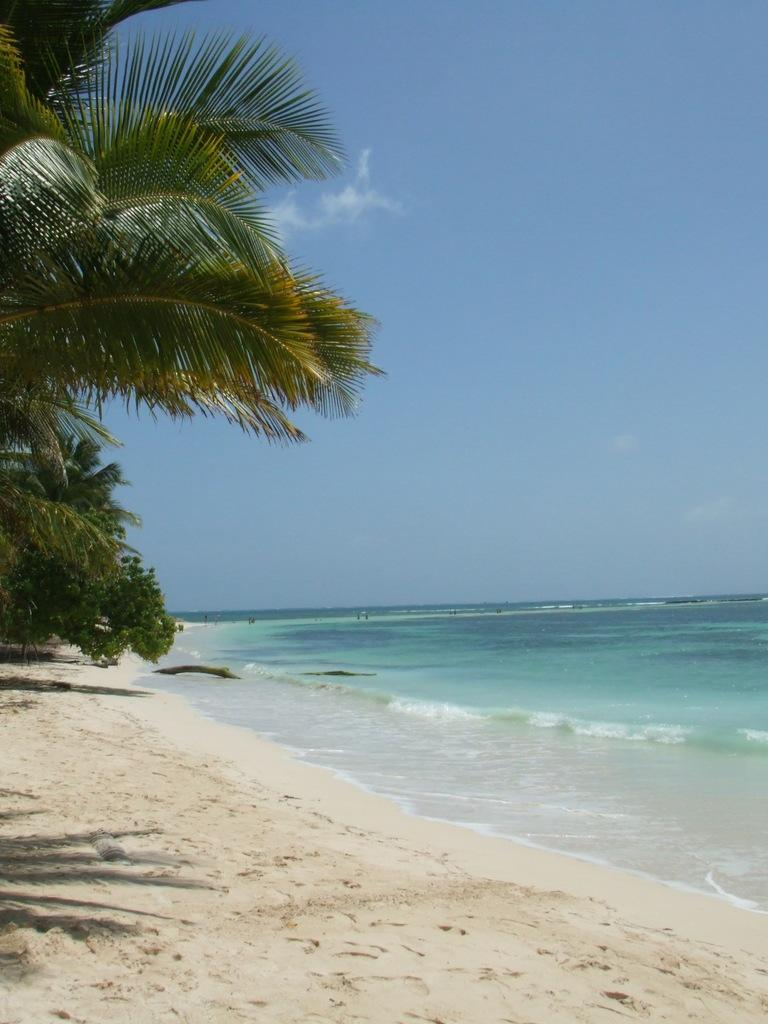What type of vegetation can be seen in the image? There are trees in the image. What type of terrain is present in the image? There is sand in the image. What natural element is visible in the image? There is water visible in the image. What can be seen in the background of the image? The background of the image includes clouds. What is visible in the sky in the image? The sky is visible in the background of the image. What type of loaf is floating in the water in the image? There is no loaf present in the image; it features trees, sand, water, clouds, and the sky. Can you see any ghosts interacting with the trees in the image? There are no ghosts present in the image; it only features trees, sand, water, clouds, and the sky. 